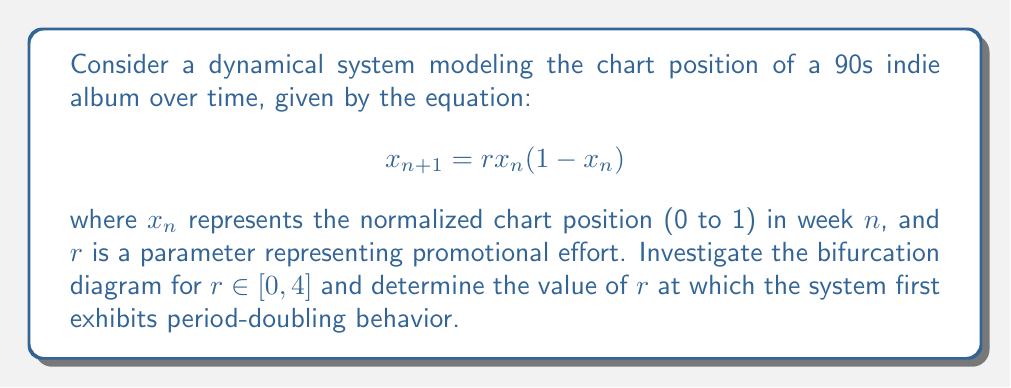Provide a solution to this math problem. To investigate the bifurcation diagram and find the first period-doubling point:

1) The given equation is the logistic map, a classic example of how complex behavior can arise from simple nonlinear dynamical systems.

2) For $0 \leq r \leq 1$, the system has only one fixed point at $x=0$.

3) At $r=1$, a transcritical bifurcation occurs, and a new stable fixed point emerges:
   $$x^* = 1 - \frac{1}{r}$$

4) This fixed point is stable for $1 < r < 3$.

5) To find the period-doubling point, we need to solve for when the stability of the fixed point changes. This occurs when the absolute value of the derivative at the fixed point equals 1:

   $$\left|\frac{d}{dx}(rx(1-x))\right|_{x=x^*} = |2-r| = 1$$

6) Solving this equation:
   $2-r = 1$ or $2-r = -1$
   $r = 1$ or $r = 3$

7) Since we're looking for the first period-doubling point after the stable fixed point regime, we choose $r = 3$.

8) After this point, the system oscillates between two values, then four, then eight, and so on, leading to chaos.

9) This cascading period-doubling behavior is reminiscent of how some albums might fluctuate in popularity week to week, sometimes stabilizing, sometimes showing erratic chart movements.
Answer: $r = 3$ 